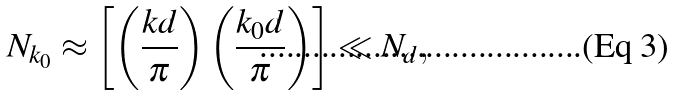<formula> <loc_0><loc_0><loc_500><loc_500>N _ { k _ { 0 } } \approx \left [ \left ( \frac { k d } { \pi } \right ) \left ( \frac { k _ { 0 } d } { \pi } \right ) \right ] \ll N _ { d } ,</formula> 